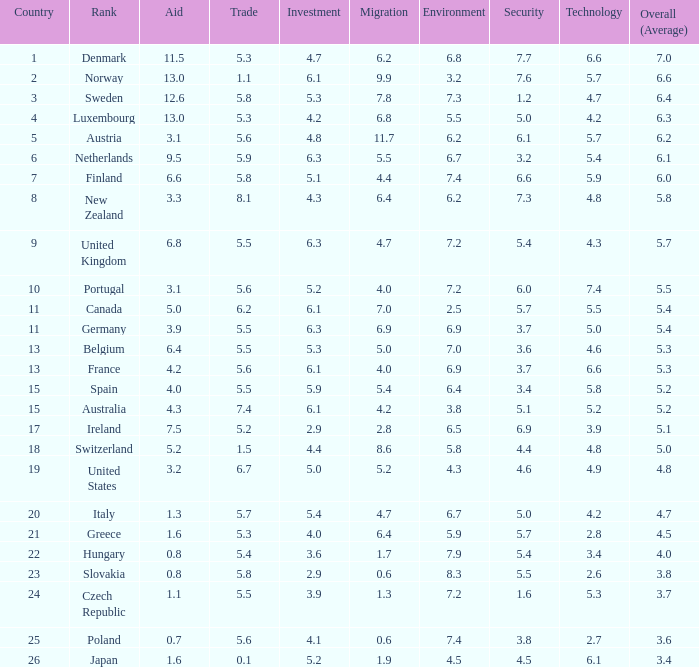5 score for safety? Slovakia. 